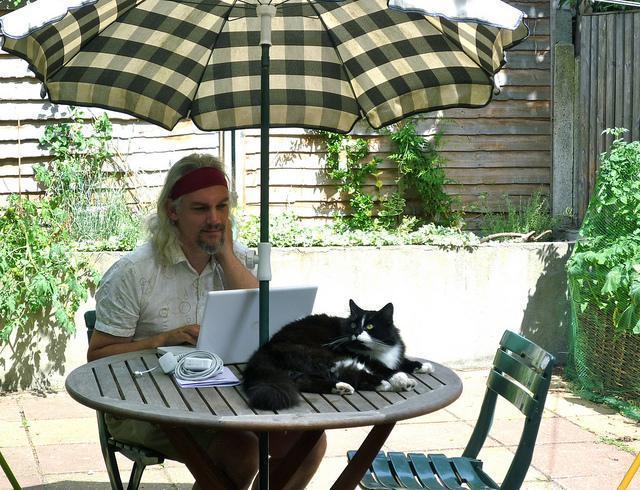How many chairs can you see?
Give a very brief answer. 2. How many laptops are in the photo?
Give a very brief answer. 1. How many dining tables can be seen?
Give a very brief answer. 1. 